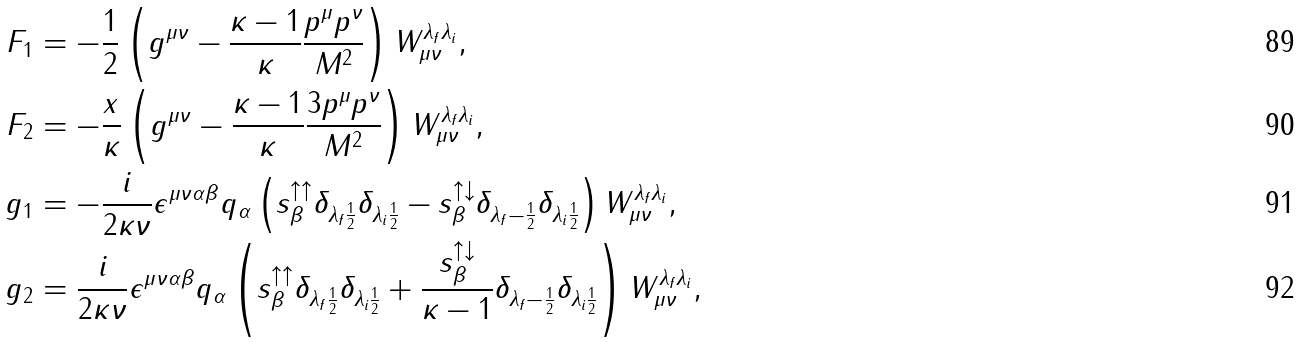Convert formula to latex. <formula><loc_0><loc_0><loc_500><loc_500>\, F _ { 1 } & = - \frac { 1 } { 2 } \left ( g ^ { \mu \nu } - \frac { \kappa - 1 } { \kappa } \frac { p ^ { \mu } p ^ { \nu } } { M ^ { 2 } } \right ) W _ { \mu \nu } ^ { \lambda _ { f } \lambda _ { i } } , \\ \, F _ { 2 } & = - \frac { x } { \kappa } \left ( g ^ { \mu \nu } - \frac { \kappa - 1 } { \kappa } \frac { 3 p ^ { \mu } p ^ { \nu } } { M ^ { 2 } } \right ) W _ { \mu \nu } ^ { \lambda _ { f } \lambda _ { i } } , \\ \, g _ { 1 } & = - \frac { i } { 2 \kappa \nu } \epsilon ^ { \mu \nu \alpha \beta } q _ { \alpha } \left ( s _ { \beta } ^ { \uparrow \uparrow } \delta _ { \lambda _ { f } \frac { 1 } { 2 } } \delta _ { \lambda _ { i } \frac { 1 } { 2 } } - s _ { \beta } ^ { \uparrow \downarrow } \delta _ { \lambda _ { f } - \frac { 1 } { 2 } } \delta _ { \lambda _ { i } \frac { 1 } { 2 } } \right ) W _ { \mu \nu } ^ { \lambda _ { f } \lambda _ { i } } , \\ \, g _ { 2 } & = \frac { i } { 2 \kappa \nu } \epsilon ^ { \mu \nu \alpha \beta } q _ { \alpha } \left ( s _ { \beta } ^ { \uparrow \uparrow } \delta _ { \lambda _ { f } \frac { 1 } { 2 } } \delta _ { \lambda _ { i } \frac { 1 } { 2 } } + \frac { s _ { \beta } ^ { \uparrow \downarrow } } { \kappa - 1 } \delta _ { \lambda _ { f } - \frac { 1 } { 2 } } \delta _ { \lambda _ { i } \frac { 1 } { 2 } } \right ) W _ { \mu \nu } ^ { \lambda _ { f } \lambda _ { i } } ,</formula> 